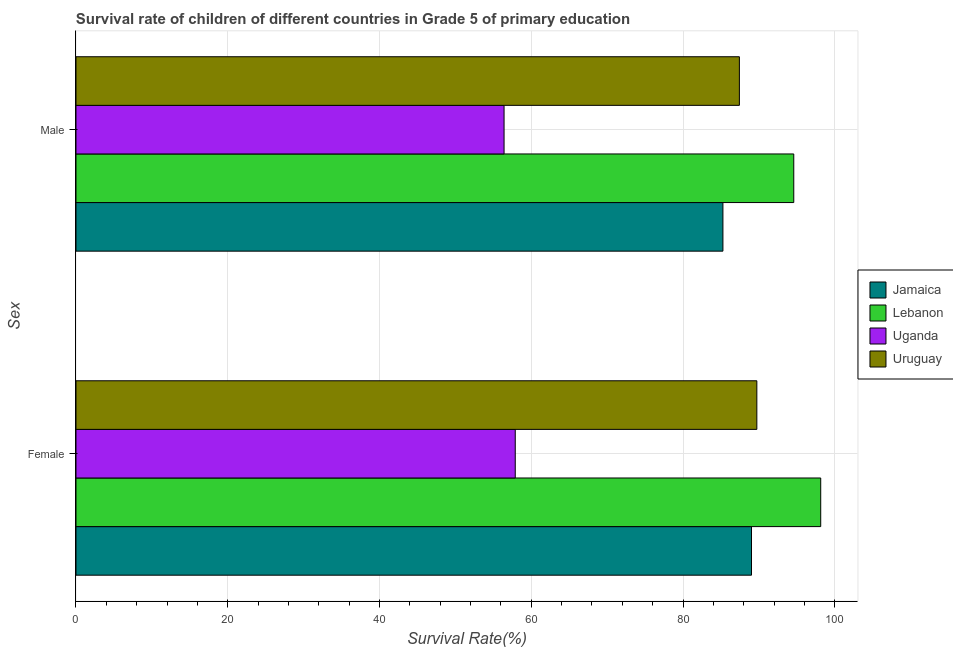How many different coloured bars are there?
Provide a succinct answer. 4. How many groups of bars are there?
Offer a very short reply. 2. Are the number of bars per tick equal to the number of legend labels?
Offer a very short reply. Yes. How many bars are there on the 2nd tick from the top?
Make the answer very short. 4. What is the label of the 1st group of bars from the top?
Make the answer very short. Male. What is the survival rate of male students in primary education in Uruguay?
Make the answer very short. 87.43. Across all countries, what is the maximum survival rate of male students in primary education?
Your response must be concise. 94.6. Across all countries, what is the minimum survival rate of female students in primary education?
Ensure brevity in your answer.  57.89. In which country was the survival rate of female students in primary education maximum?
Provide a succinct answer. Lebanon. In which country was the survival rate of female students in primary education minimum?
Your answer should be compact. Uganda. What is the total survival rate of female students in primary education in the graph?
Keep it short and to the point. 334.81. What is the difference between the survival rate of female students in primary education in Jamaica and that in Lebanon?
Your response must be concise. -9.12. What is the difference between the survival rate of male students in primary education in Uruguay and the survival rate of female students in primary education in Lebanon?
Provide a succinct answer. -10.72. What is the average survival rate of male students in primary education per country?
Make the answer very short. 80.93. What is the difference between the survival rate of female students in primary education and survival rate of male students in primary education in Lebanon?
Your answer should be compact. 3.55. What is the ratio of the survival rate of male students in primary education in Uruguay to that in Jamaica?
Give a very brief answer. 1.03. What does the 1st bar from the top in Female represents?
Your response must be concise. Uruguay. What does the 4th bar from the bottom in Female represents?
Ensure brevity in your answer.  Uruguay. How many bars are there?
Provide a succinct answer. 8. Are all the bars in the graph horizontal?
Provide a short and direct response. Yes. How many countries are there in the graph?
Ensure brevity in your answer.  4. What is the difference between two consecutive major ticks on the X-axis?
Your answer should be very brief. 20. How are the legend labels stacked?
Your answer should be very brief. Vertical. What is the title of the graph?
Make the answer very short. Survival rate of children of different countries in Grade 5 of primary education. What is the label or title of the X-axis?
Your response must be concise. Survival Rate(%). What is the label or title of the Y-axis?
Provide a succinct answer. Sex. What is the Survival Rate(%) in Jamaica in Female?
Ensure brevity in your answer.  89.03. What is the Survival Rate(%) in Lebanon in Female?
Your response must be concise. 98.15. What is the Survival Rate(%) in Uganda in Female?
Keep it short and to the point. 57.89. What is the Survival Rate(%) of Uruguay in Female?
Your answer should be very brief. 89.73. What is the Survival Rate(%) of Jamaica in Male?
Your answer should be compact. 85.26. What is the Survival Rate(%) in Lebanon in Male?
Ensure brevity in your answer.  94.6. What is the Survival Rate(%) in Uganda in Male?
Give a very brief answer. 56.42. What is the Survival Rate(%) of Uruguay in Male?
Offer a terse response. 87.43. Across all Sex, what is the maximum Survival Rate(%) in Jamaica?
Ensure brevity in your answer.  89.03. Across all Sex, what is the maximum Survival Rate(%) in Lebanon?
Your answer should be very brief. 98.15. Across all Sex, what is the maximum Survival Rate(%) of Uganda?
Provide a succinct answer. 57.89. Across all Sex, what is the maximum Survival Rate(%) of Uruguay?
Your response must be concise. 89.73. Across all Sex, what is the minimum Survival Rate(%) in Jamaica?
Your answer should be compact. 85.26. Across all Sex, what is the minimum Survival Rate(%) of Lebanon?
Offer a terse response. 94.6. Across all Sex, what is the minimum Survival Rate(%) of Uganda?
Offer a terse response. 56.42. Across all Sex, what is the minimum Survival Rate(%) in Uruguay?
Make the answer very short. 87.43. What is the total Survival Rate(%) in Jamaica in the graph?
Provide a succinct answer. 174.29. What is the total Survival Rate(%) of Lebanon in the graph?
Your answer should be compact. 192.75. What is the total Survival Rate(%) of Uganda in the graph?
Offer a very short reply. 114.31. What is the total Survival Rate(%) in Uruguay in the graph?
Your response must be concise. 177.16. What is the difference between the Survival Rate(%) of Jamaica in Female and that in Male?
Ensure brevity in your answer.  3.77. What is the difference between the Survival Rate(%) in Lebanon in Female and that in Male?
Your answer should be compact. 3.55. What is the difference between the Survival Rate(%) of Uganda in Female and that in Male?
Ensure brevity in your answer.  1.48. What is the difference between the Survival Rate(%) of Uruguay in Female and that in Male?
Offer a terse response. 2.3. What is the difference between the Survival Rate(%) of Jamaica in Female and the Survival Rate(%) of Lebanon in Male?
Your answer should be compact. -5.57. What is the difference between the Survival Rate(%) of Jamaica in Female and the Survival Rate(%) of Uganda in Male?
Your answer should be compact. 32.61. What is the difference between the Survival Rate(%) in Jamaica in Female and the Survival Rate(%) in Uruguay in Male?
Offer a terse response. 1.6. What is the difference between the Survival Rate(%) of Lebanon in Female and the Survival Rate(%) of Uganda in Male?
Your answer should be very brief. 41.73. What is the difference between the Survival Rate(%) in Lebanon in Female and the Survival Rate(%) in Uruguay in Male?
Make the answer very short. 10.72. What is the difference between the Survival Rate(%) of Uganda in Female and the Survival Rate(%) of Uruguay in Male?
Your answer should be compact. -29.54. What is the average Survival Rate(%) of Jamaica per Sex?
Your answer should be compact. 87.14. What is the average Survival Rate(%) in Lebanon per Sex?
Ensure brevity in your answer.  96.38. What is the average Survival Rate(%) of Uganda per Sex?
Make the answer very short. 57.16. What is the average Survival Rate(%) of Uruguay per Sex?
Your answer should be compact. 88.58. What is the difference between the Survival Rate(%) in Jamaica and Survival Rate(%) in Lebanon in Female?
Your answer should be very brief. -9.12. What is the difference between the Survival Rate(%) of Jamaica and Survival Rate(%) of Uganda in Female?
Provide a short and direct response. 31.14. What is the difference between the Survival Rate(%) of Jamaica and Survival Rate(%) of Uruguay in Female?
Make the answer very short. -0.7. What is the difference between the Survival Rate(%) in Lebanon and Survival Rate(%) in Uganda in Female?
Offer a terse response. 40.26. What is the difference between the Survival Rate(%) in Lebanon and Survival Rate(%) in Uruguay in Female?
Provide a short and direct response. 8.42. What is the difference between the Survival Rate(%) of Uganda and Survival Rate(%) of Uruguay in Female?
Offer a terse response. -31.84. What is the difference between the Survival Rate(%) of Jamaica and Survival Rate(%) of Lebanon in Male?
Make the answer very short. -9.34. What is the difference between the Survival Rate(%) of Jamaica and Survival Rate(%) of Uganda in Male?
Give a very brief answer. 28.84. What is the difference between the Survival Rate(%) in Jamaica and Survival Rate(%) in Uruguay in Male?
Your answer should be compact. -2.17. What is the difference between the Survival Rate(%) in Lebanon and Survival Rate(%) in Uganda in Male?
Provide a short and direct response. 38.18. What is the difference between the Survival Rate(%) in Lebanon and Survival Rate(%) in Uruguay in Male?
Provide a succinct answer. 7.17. What is the difference between the Survival Rate(%) in Uganda and Survival Rate(%) in Uruguay in Male?
Offer a very short reply. -31.02. What is the ratio of the Survival Rate(%) in Jamaica in Female to that in Male?
Provide a succinct answer. 1.04. What is the ratio of the Survival Rate(%) in Lebanon in Female to that in Male?
Your response must be concise. 1.04. What is the ratio of the Survival Rate(%) in Uganda in Female to that in Male?
Keep it short and to the point. 1.03. What is the ratio of the Survival Rate(%) in Uruguay in Female to that in Male?
Your answer should be very brief. 1.03. What is the difference between the highest and the second highest Survival Rate(%) in Jamaica?
Your response must be concise. 3.77. What is the difference between the highest and the second highest Survival Rate(%) in Lebanon?
Offer a terse response. 3.55. What is the difference between the highest and the second highest Survival Rate(%) of Uganda?
Offer a terse response. 1.48. What is the difference between the highest and the second highest Survival Rate(%) in Uruguay?
Offer a very short reply. 2.3. What is the difference between the highest and the lowest Survival Rate(%) of Jamaica?
Your response must be concise. 3.77. What is the difference between the highest and the lowest Survival Rate(%) of Lebanon?
Make the answer very short. 3.55. What is the difference between the highest and the lowest Survival Rate(%) of Uganda?
Make the answer very short. 1.48. What is the difference between the highest and the lowest Survival Rate(%) in Uruguay?
Ensure brevity in your answer.  2.3. 